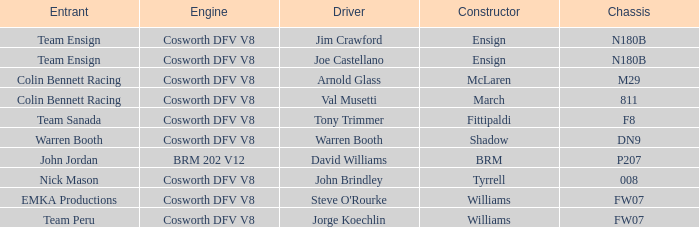What team used the BRM built car? John Jordan. 